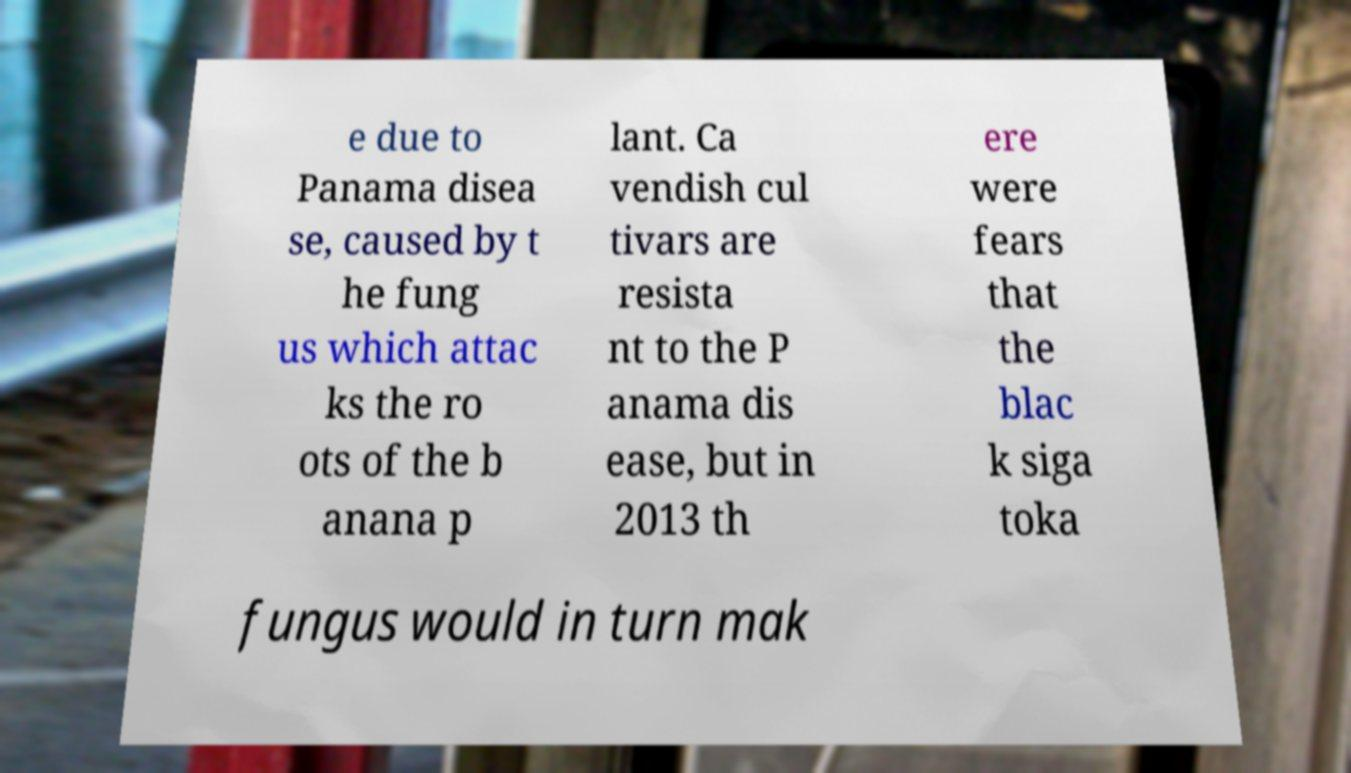I need the written content from this picture converted into text. Can you do that? e due to Panama disea se, caused by t he fung us which attac ks the ro ots of the b anana p lant. Ca vendish cul tivars are resista nt to the P anama dis ease, but in 2013 th ere were fears that the blac k siga toka fungus would in turn mak 